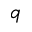Convert formula to latex. <formula><loc_0><loc_0><loc_500><loc_500>q</formula> 